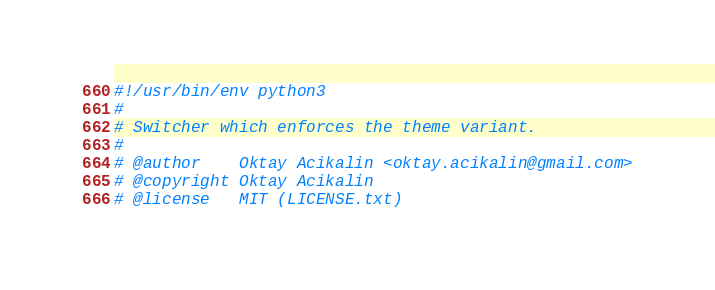<code> <loc_0><loc_0><loc_500><loc_500><_Python_>#!/usr/bin/env python3
#
# Switcher which enforces the theme variant.
#
# @author    Oktay Acikalin <oktay.acikalin@gmail.com>
# @copyright Oktay Acikalin
# @license   MIT (LICENSE.txt)
</code> 